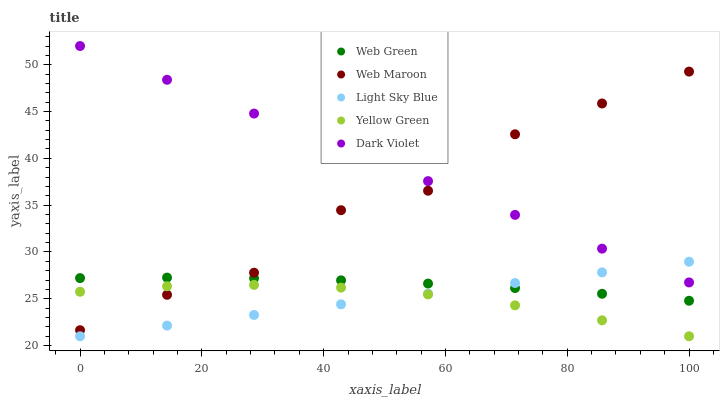Does Yellow Green have the minimum area under the curve?
Answer yes or no. Yes. Does Dark Violet have the maximum area under the curve?
Answer yes or no. Yes. Does Light Sky Blue have the minimum area under the curve?
Answer yes or no. No. Does Light Sky Blue have the maximum area under the curve?
Answer yes or no. No. Is Light Sky Blue the smoothest?
Answer yes or no. Yes. Is Web Maroon the roughest?
Answer yes or no. Yes. Is Web Maroon the smoothest?
Answer yes or no. No. Is Light Sky Blue the roughest?
Answer yes or no. No. Does Light Sky Blue have the lowest value?
Answer yes or no. Yes. Does Web Maroon have the lowest value?
Answer yes or no. No. Does Dark Violet have the highest value?
Answer yes or no. Yes. Does Light Sky Blue have the highest value?
Answer yes or no. No. Is Light Sky Blue less than Web Maroon?
Answer yes or no. Yes. Is Dark Violet greater than Yellow Green?
Answer yes or no. Yes. Does Web Maroon intersect Dark Violet?
Answer yes or no. Yes. Is Web Maroon less than Dark Violet?
Answer yes or no. No. Is Web Maroon greater than Dark Violet?
Answer yes or no. No. Does Light Sky Blue intersect Web Maroon?
Answer yes or no. No. 